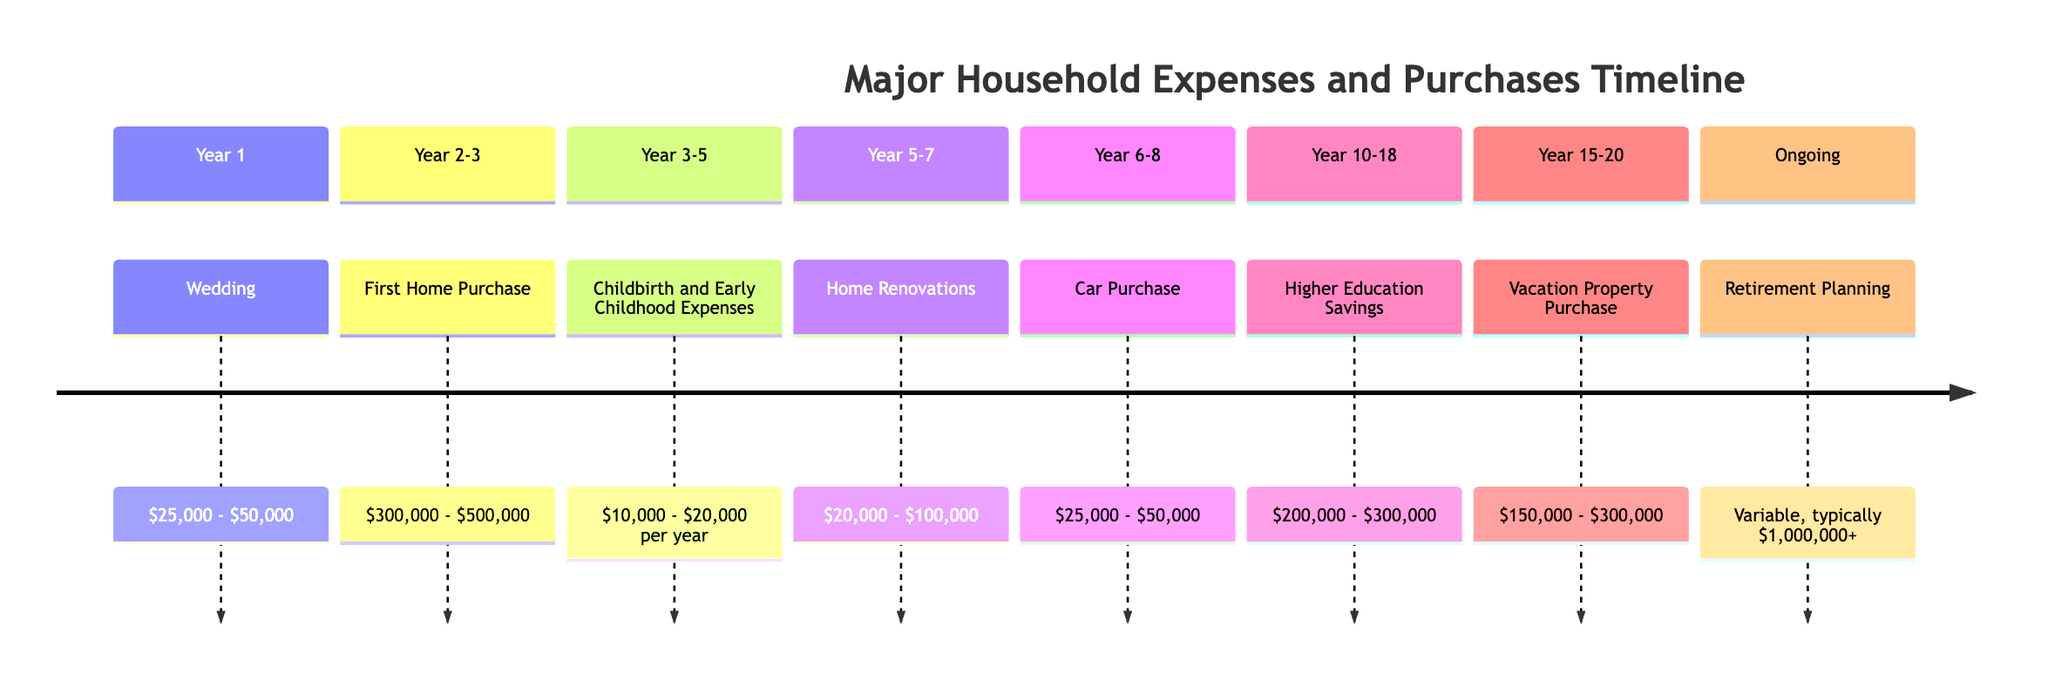What is the expected cost of the wedding? The first event on the timeline is "Wedding," which has an expected cost ranging from $25,000 to $50,000. This information can be found in the corresponding section of the timeline.
Answer: $25,000 - $50,000 In which years do childbirth expenses occur? The timeline indicates that childbirth and early childhood expenses are expected to occur between Year 3 and Year 5. This is specified at the section where this event is listed.
Answer: Year 3 - 5 What is the financial impact of buying a first home? The "First Home Purchase" event notes that it is a major long-term investment impacting various expenses like mortgage payments, property taxes, and insurance. This information is found under its event description.
Answer: Major long-term investment How many events are listed between Years 2 and 3? The timeline includes one event during Years 2-3, which is the "First Home Purchase." This can be counted by reviewing the specified sections in the timeline.
Answer: 1 What is the expected cost range for higher education savings? The section for "Higher Education Savings" indicates an expected cost range of $200,000 to $300,000. This data can be directly read from the section related to that event.
Answer: $200,000 - $300,000 During which years does car purchasing occur? The timeline details that car purchases happen between Year 6 to Year 8. This is indicated in the section where the car purchase event is placed.
Answer: Year 6 - 8 What is the primary financial impact of retirement planning? The financial impact of retirement planning is described as a long-term savings goal requiring a diversified investment strategy. This key information is derived from the retirement section of the timeline.
Answer: Long-term savings goal What is the relationship between home renovations, home equity, and resale value? The home renovations event specifies that this significant one-time cost may increase home equity and resale value. Understanding this requires linking the event to its financial impact shown in the timeline.
Answer: Increases home equity and resale value What is the cost range of the vacation property purchase? The vacation property purchase section specifies that the expected cost is between $150,000 and $300,000. This information is found directly from the relevant section of the timeline.
Answer: $150,000 - $300,000 